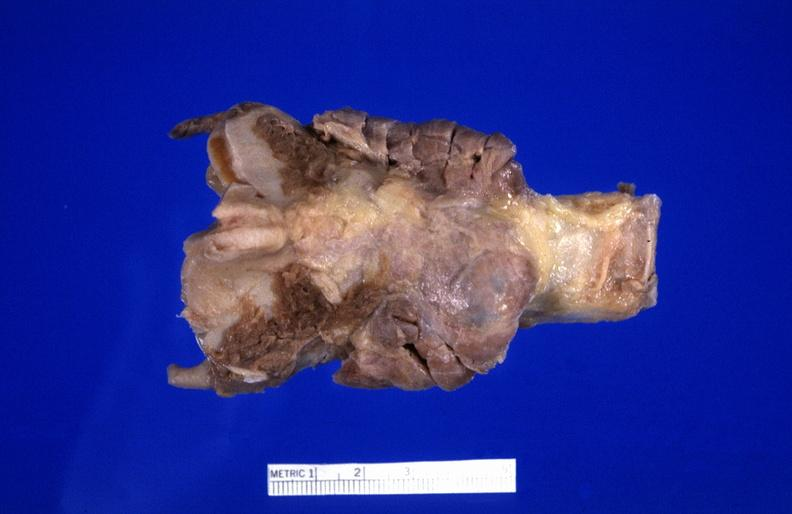s endocrine present?
Answer the question using a single word or phrase. Yes 